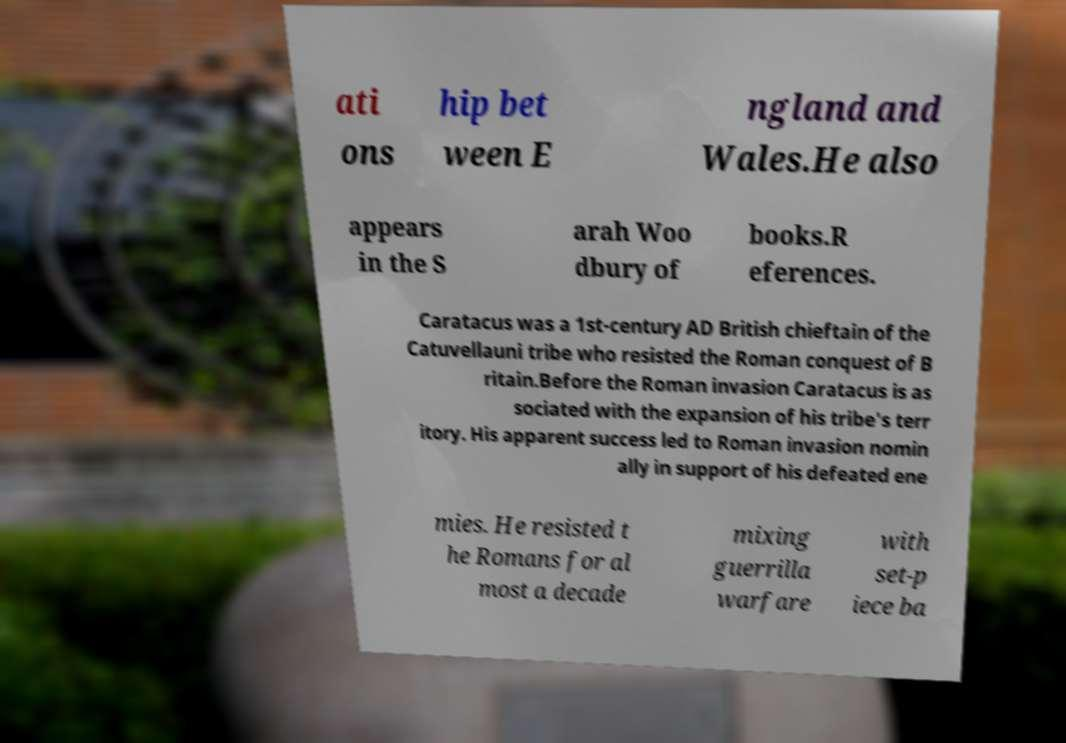Can you read and provide the text displayed in the image?This photo seems to have some interesting text. Can you extract and type it out for me? ati ons hip bet ween E ngland and Wales.He also appears in the S arah Woo dbury of books.R eferences. Caratacus was a 1st-century AD British chieftain of the Catuvellauni tribe who resisted the Roman conquest of B ritain.Before the Roman invasion Caratacus is as sociated with the expansion of his tribe's terr itory. His apparent success led to Roman invasion nomin ally in support of his defeated ene mies. He resisted t he Romans for al most a decade mixing guerrilla warfare with set-p iece ba 